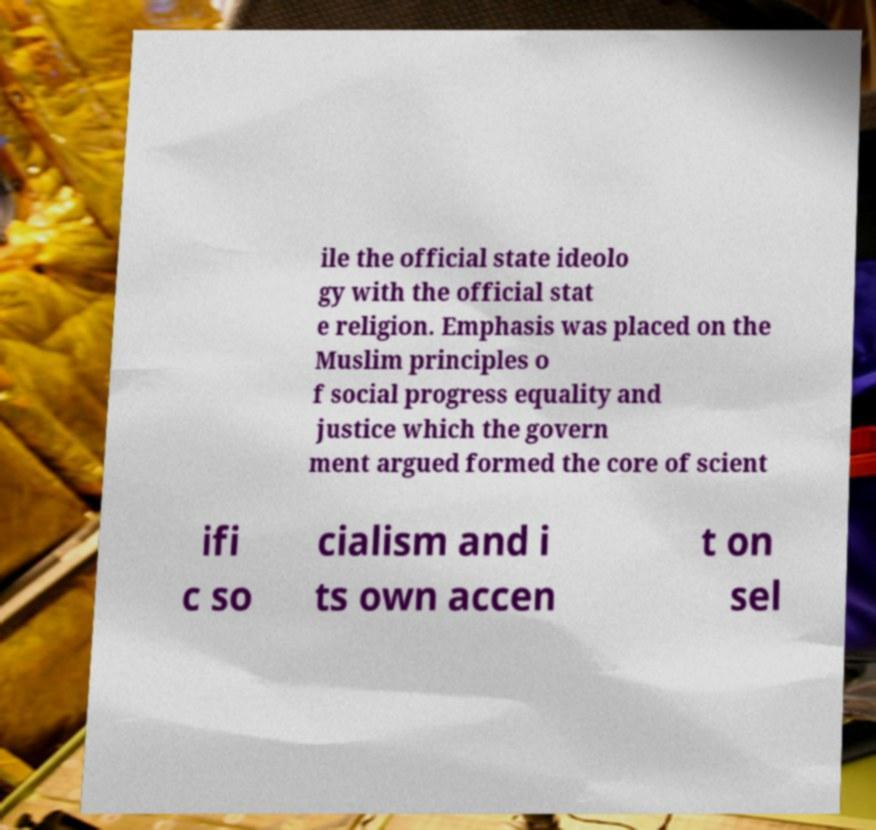Please read and relay the text visible in this image. What does it say? ile the official state ideolo gy with the official stat e religion. Emphasis was placed on the Muslim principles o f social progress equality and justice which the govern ment argued formed the core of scient ifi c so cialism and i ts own accen t on sel 